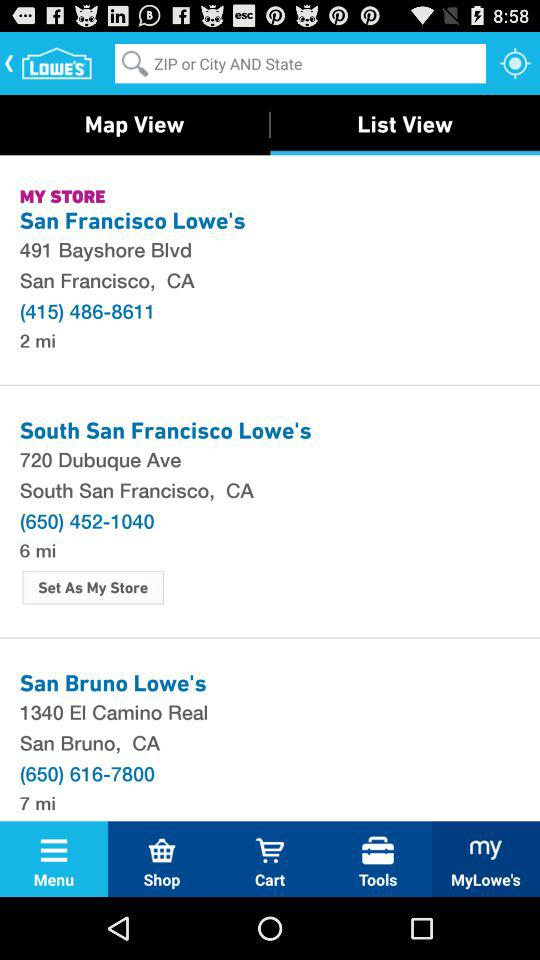What is the address of the San Francisco Loweś? The address is 491 Bayshore Blvd, 491 Bayshore Blvd. 